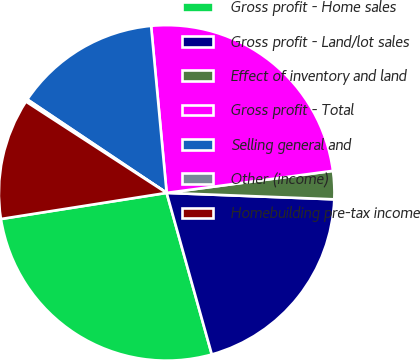Convert chart to OTSL. <chart><loc_0><loc_0><loc_500><loc_500><pie_chart><fcel>Gross profit - Home sales<fcel>Gross profit - Land/lot sales<fcel>Effect of inventory and land<fcel>Gross profit - Total<fcel>Selling general and<fcel>Other (income)<fcel>Homebuilding pre-tax income<nl><fcel>26.85%<fcel>20.05%<fcel>2.71%<fcel>24.38%<fcel>14.12%<fcel>0.24%<fcel>11.65%<nl></chart> 